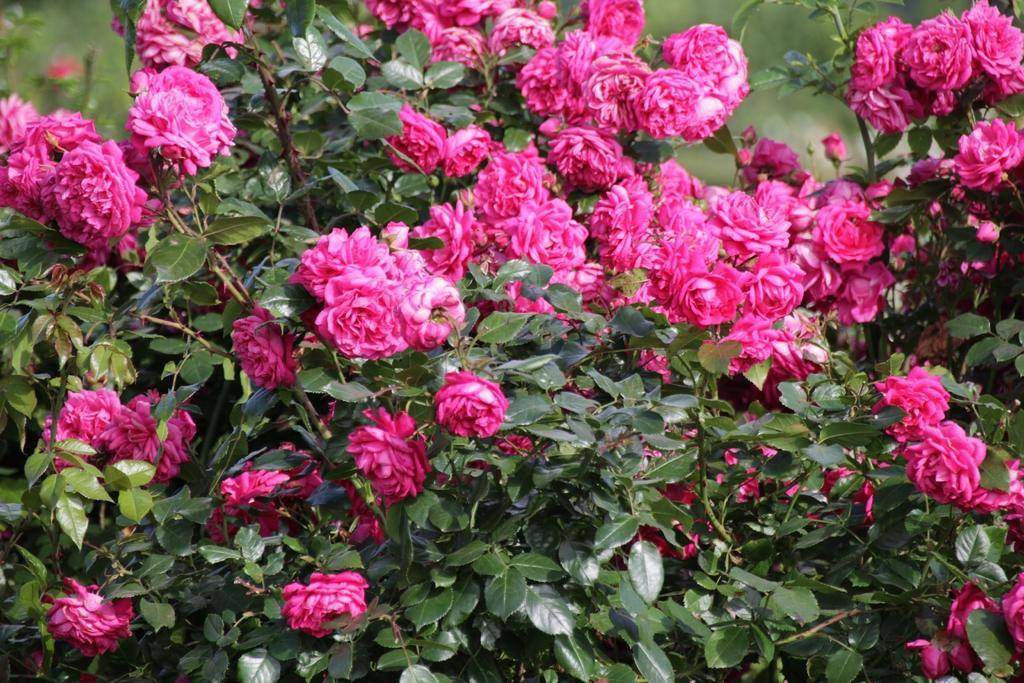What type of plant is in the image? There is a plant in the image with rose flowers. What color are the rose flowers? The rose flowers in the image are pink-colored. What other part of the plant can be seen in the image? There are green-colored leaves on the plant. Are all the rose flowers fully bloomed in the image? No, some of the rose flowers have buds. What type of animal can be seen interacting with the cactus in the image? There is no cactus or animal present in the image; it features a plant with rose flowers. How does the tramp contribute to the growth of the plant in the image? There is no tramp present in the image, and therefore it cannot contribute to the growth of the plant. 